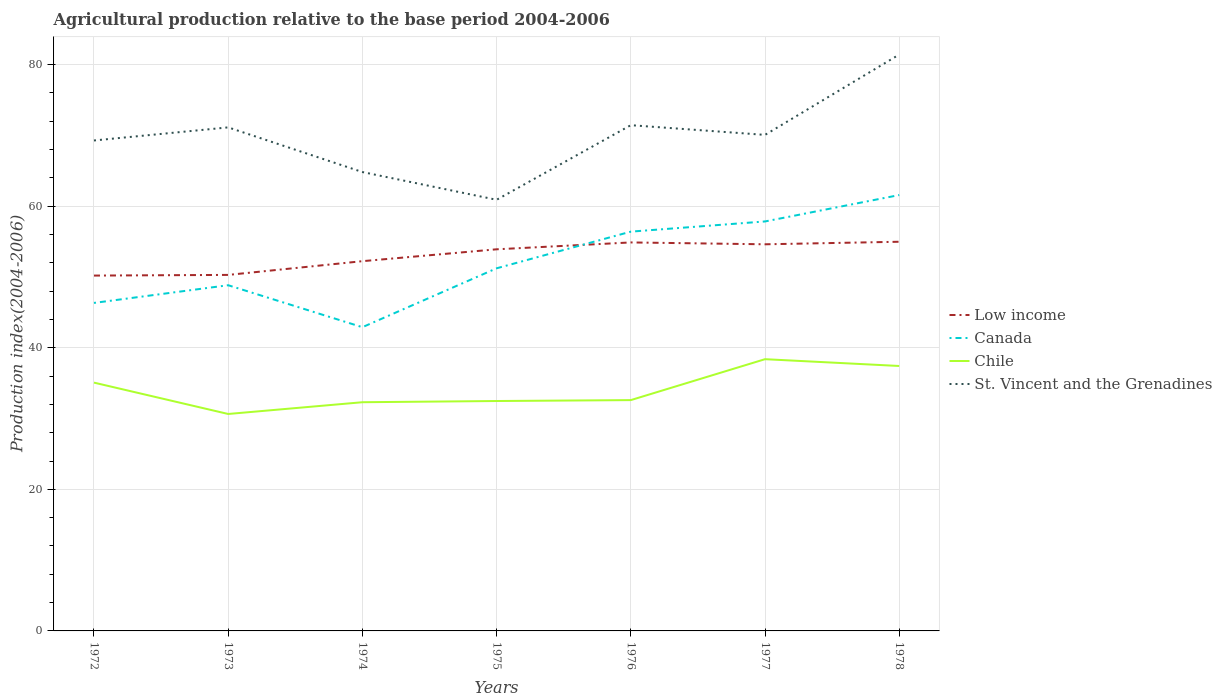Does the line corresponding to Chile intersect with the line corresponding to Canada?
Offer a very short reply. No. Is the number of lines equal to the number of legend labels?
Offer a very short reply. Yes. Across all years, what is the maximum agricultural production index in Low income?
Ensure brevity in your answer.  50.2. In which year was the agricultural production index in Canada maximum?
Keep it short and to the point. 1974. What is the total agricultural production index in Chile in the graph?
Keep it short and to the point. -0.13. What is the difference between the highest and the second highest agricultural production index in St. Vincent and the Grenadines?
Make the answer very short. 20.52. What is the difference between two consecutive major ticks on the Y-axis?
Provide a short and direct response. 20. Are the values on the major ticks of Y-axis written in scientific E-notation?
Your answer should be compact. No. Does the graph contain any zero values?
Make the answer very short. No. Does the graph contain grids?
Provide a short and direct response. Yes. Where does the legend appear in the graph?
Keep it short and to the point. Center right. How are the legend labels stacked?
Make the answer very short. Vertical. What is the title of the graph?
Make the answer very short. Agricultural production relative to the base period 2004-2006. What is the label or title of the X-axis?
Keep it short and to the point. Years. What is the label or title of the Y-axis?
Keep it short and to the point. Production index(2004-2006). What is the Production index(2004-2006) in Low income in 1972?
Provide a succinct answer. 50.2. What is the Production index(2004-2006) in Canada in 1972?
Provide a succinct answer. 46.34. What is the Production index(2004-2006) of Chile in 1972?
Give a very brief answer. 35.08. What is the Production index(2004-2006) of St. Vincent and the Grenadines in 1972?
Make the answer very short. 69.29. What is the Production index(2004-2006) in Low income in 1973?
Your answer should be compact. 50.3. What is the Production index(2004-2006) in Canada in 1973?
Provide a succinct answer. 48.84. What is the Production index(2004-2006) of Chile in 1973?
Offer a terse response. 30.65. What is the Production index(2004-2006) in St. Vincent and the Grenadines in 1973?
Your response must be concise. 71.14. What is the Production index(2004-2006) in Low income in 1974?
Your answer should be compact. 52.24. What is the Production index(2004-2006) in Canada in 1974?
Your answer should be very brief. 42.91. What is the Production index(2004-2006) in Chile in 1974?
Provide a short and direct response. 32.31. What is the Production index(2004-2006) of St. Vincent and the Grenadines in 1974?
Provide a succinct answer. 64.83. What is the Production index(2004-2006) of Low income in 1975?
Make the answer very short. 53.92. What is the Production index(2004-2006) of Canada in 1975?
Provide a succinct answer. 51.23. What is the Production index(2004-2006) of Chile in 1975?
Keep it short and to the point. 32.48. What is the Production index(2004-2006) of St. Vincent and the Grenadines in 1975?
Provide a short and direct response. 60.91. What is the Production index(2004-2006) in Low income in 1976?
Keep it short and to the point. 54.89. What is the Production index(2004-2006) in Canada in 1976?
Your answer should be compact. 56.41. What is the Production index(2004-2006) of Chile in 1976?
Ensure brevity in your answer.  32.61. What is the Production index(2004-2006) in St. Vincent and the Grenadines in 1976?
Ensure brevity in your answer.  71.45. What is the Production index(2004-2006) of Low income in 1977?
Your answer should be very brief. 54.62. What is the Production index(2004-2006) in Canada in 1977?
Offer a very short reply. 57.85. What is the Production index(2004-2006) of Chile in 1977?
Give a very brief answer. 38.39. What is the Production index(2004-2006) in St. Vincent and the Grenadines in 1977?
Your answer should be compact. 70.08. What is the Production index(2004-2006) in Low income in 1978?
Provide a short and direct response. 54.98. What is the Production index(2004-2006) in Canada in 1978?
Provide a short and direct response. 61.58. What is the Production index(2004-2006) in Chile in 1978?
Ensure brevity in your answer.  37.43. What is the Production index(2004-2006) in St. Vincent and the Grenadines in 1978?
Provide a short and direct response. 81.43. Across all years, what is the maximum Production index(2004-2006) of Low income?
Provide a short and direct response. 54.98. Across all years, what is the maximum Production index(2004-2006) in Canada?
Keep it short and to the point. 61.58. Across all years, what is the maximum Production index(2004-2006) of Chile?
Offer a very short reply. 38.39. Across all years, what is the maximum Production index(2004-2006) in St. Vincent and the Grenadines?
Offer a terse response. 81.43. Across all years, what is the minimum Production index(2004-2006) of Low income?
Give a very brief answer. 50.2. Across all years, what is the minimum Production index(2004-2006) in Canada?
Provide a short and direct response. 42.91. Across all years, what is the minimum Production index(2004-2006) in Chile?
Offer a very short reply. 30.65. Across all years, what is the minimum Production index(2004-2006) of St. Vincent and the Grenadines?
Provide a short and direct response. 60.91. What is the total Production index(2004-2006) in Low income in the graph?
Offer a very short reply. 371.14. What is the total Production index(2004-2006) in Canada in the graph?
Offer a terse response. 365.16. What is the total Production index(2004-2006) of Chile in the graph?
Keep it short and to the point. 238.95. What is the total Production index(2004-2006) in St. Vincent and the Grenadines in the graph?
Offer a terse response. 489.13. What is the difference between the Production index(2004-2006) of Low income in 1972 and that in 1973?
Provide a succinct answer. -0.09. What is the difference between the Production index(2004-2006) in Chile in 1972 and that in 1973?
Provide a succinct answer. 4.43. What is the difference between the Production index(2004-2006) in St. Vincent and the Grenadines in 1972 and that in 1973?
Give a very brief answer. -1.85. What is the difference between the Production index(2004-2006) of Low income in 1972 and that in 1974?
Your answer should be compact. -2.03. What is the difference between the Production index(2004-2006) in Canada in 1972 and that in 1974?
Provide a short and direct response. 3.43. What is the difference between the Production index(2004-2006) in Chile in 1972 and that in 1974?
Keep it short and to the point. 2.77. What is the difference between the Production index(2004-2006) of St. Vincent and the Grenadines in 1972 and that in 1974?
Your answer should be compact. 4.46. What is the difference between the Production index(2004-2006) in Low income in 1972 and that in 1975?
Offer a very short reply. -3.71. What is the difference between the Production index(2004-2006) of Canada in 1972 and that in 1975?
Keep it short and to the point. -4.89. What is the difference between the Production index(2004-2006) of Chile in 1972 and that in 1975?
Ensure brevity in your answer.  2.6. What is the difference between the Production index(2004-2006) of St. Vincent and the Grenadines in 1972 and that in 1975?
Provide a succinct answer. 8.38. What is the difference between the Production index(2004-2006) in Low income in 1972 and that in 1976?
Offer a very short reply. -4.68. What is the difference between the Production index(2004-2006) of Canada in 1972 and that in 1976?
Offer a very short reply. -10.07. What is the difference between the Production index(2004-2006) of Chile in 1972 and that in 1976?
Your answer should be compact. 2.47. What is the difference between the Production index(2004-2006) of St. Vincent and the Grenadines in 1972 and that in 1976?
Offer a very short reply. -2.16. What is the difference between the Production index(2004-2006) in Low income in 1972 and that in 1977?
Your response must be concise. -4.42. What is the difference between the Production index(2004-2006) in Canada in 1972 and that in 1977?
Your answer should be compact. -11.51. What is the difference between the Production index(2004-2006) of Chile in 1972 and that in 1977?
Make the answer very short. -3.31. What is the difference between the Production index(2004-2006) of St. Vincent and the Grenadines in 1972 and that in 1977?
Your answer should be compact. -0.79. What is the difference between the Production index(2004-2006) in Low income in 1972 and that in 1978?
Your answer should be compact. -4.78. What is the difference between the Production index(2004-2006) of Canada in 1972 and that in 1978?
Your response must be concise. -15.24. What is the difference between the Production index(2004-2006) of Chile in 1972 and that in 1978?
Offer a very short reply. -2.35. What is the difference between the Production index(2004-2006) of St. Vincent and the Grenadines in 1972 and that in 1978?
Offer a terse response. -12.14. What is the difference between the Production index(2004-2006) in Low income in 1973 and that in 1974?
Offer a very short reply. -1.94. What is the difference between the Production index(2004-2006) of Canada in 1973 and that in 1974?
Provide a succinct answer. 5.93. What is the difference between the Production index(2004-2006) of Chile in 1973 and that in 1974?
Ensure brevity in your answer.  -1.66. What is the difference between the Production index(2004-2006) of St. Vincent and the Grenadines in 1973 and that in 1974?
Make the answer very short. 6.31. What is the difference between the Production index(2004-2006) in Low income in 1973 and that in 1975?
Your answer should be compact. -3.62. What is the difference between the Production index(2004-2006) in Canada in 1973 and that in 1975?
Offer a very short reply. -2.39. What is the difference between the Production index(2004-2006) of Chile in 1973 and that in 1975?
Your response must be concise. -1.83. What is the difference between the Production index(2004-2006) in St. Vincent and the Grenadines in 1973 and that in 1975?
Offer a terse response. 10.23. What is the difference between the Production index(2004-2006) in Low income in 1973 and that in 1976?
Your answer should be very brief. -4.59. What is the difference between the Production index(2004-2006) in Canada in 1973 and that in 1976?
Your answer should be very brief. -7.57. What is the difference between the Production index(2004-2006) in Chile in 1973 and that in 1976?
Your answer should be compact. -1.96. What is the difference between the Production index(2004-2006) in St. Vincent and the Grenadines in 1973 and that in 1976?
Make the answer very short. -0.31. What is the difference between the Production index(2004-2006) of Low income in 1973 and that in 1977?
Your response must be concise. -4.32. What is the difference between the Production index(2004-2006) of Canada in 1973 and that in 1977?
Offer a terse response. -9.01. What is the difference between the Production index(2004-2006) of Chile in 1973 and that in 1977?
Give a very brief answer. -7.74. What is the difference between the Production index(2004-2006) of St. Vincent and the Grenadines in 1973 and that in 1977?
Offer a very short reply. 1.06. What is the difference between the Production index(2004-2006) of Low income in 1973 and that in 1978?
Provide a succinct answer. -4.68. What is the difference between the Production index(2004-2006) in Canada in 1973 and that in 1978?
Provide a succinct answer. -12.74. What is the difference between the Production index(2004-2006) in Chile in 1973 and that in 1978?
Keep it short and to the point. -6.78. What is the difference between the Production index(2004-2006) in St. Vincent and the Grenadines in 1973 and that in 1978?
Offer a terse response. -10.29. What is the difference between the Production index(2004-2006) of Low income in 1974 and that in 1975?
Your answer should be compact. -1.68. What is the difference between the Production index(2004-2006) of Canada in 1974 and that in 1975?
Your answer should be compact. -8.32. What is the difference between the Production index(2004-2006) in Chile in 1974 and that in 1975?
Keep it short and to the point. -0.17. What is the difference between the Production index(2004-2006) of St. Vincent and the Grenadines in 1974 and that in 1975?
Keep it short and to the point. 3.92. What is the difference between the Production index(2004-2006) of Low income in 1974 and that in 1976?
Keep it short and to the point. -2.65. What is the difference between the Production index(2004-2006) of St. Vincent and the Grenadines in 1974 and that in 1976?
Your answer should be very brief. -6.62. What is the difference between the Production index(2004-2006) in Low income in 1974 and that in 1977?
Your response must be concise. -2.39. What is the difference between the Production index(2004-2006) of Canada in 1974 and that in 1977?
Offer a very short reply. -14.94. What is the difference between the Production index(2004-2006) of Chile in 1974 and that in 1977?
Provide a succinct answer. -6.08. What is the difference between the Production index(2004-2006) of St. Vincent and the Grenadines in 1974 and that in 1977?
Provide a short and direct response. -5.25. What is the difference between the Production index(2004-2006) in Low income in 1974 and that in 1978?
Offer a very short reply. -2.75. What is the difference between the Production index(2004-2006) of Canada in 1974 and that in 1978?
Keep it short and to the point. -18.67. What is the difference between the Production index(2004-2006) of Chile in 1974 and that in 1978?
Provide a succinct answer. -5.12. What is the difference between the Production index(2004-2006) of St. Vincent and the Grenadines in 1974 and that in 1978?
Offer a very short reply. -16.6. What is the difference between the Production index(2004-2006) of Low income in 1975 and that in 1976?
Give a very brief answer. -0.97. What is the difference between the Production index(2004-2006) of Canada in 1975 and that in 1976?
Make the answer very short. -5.18. What is the difference between the Production index(2004-2006) in Chile in 1975 and that in 1976?
Give a very brief answer. -0.13. What is the difference between the Production index(2004-2006) in St. Vincent and the Grenadines in 1975 and that in 1976?
Your response must be concise. -10.54. What is the difference between the Production index(2004-2006) in Low income in 1975 and that in 1977?
Make the answer very short. -0.71. What is the difference between the Production index(2004-2006) of Canada in 1975 and that in 1977?
Keep it short and to the point. -6.62. What is the difference between the Production index(2004-2006) of Chile in 1975 and that in 1977?
Your answer should be compact. -5.91. What is the difference between the Production index(2004-2006) in St. Vincent and the Grenadines in 1975 and that in 1977?
Provide a succinct answer. -9.17. What is the difference between the Production index(2004-2006) of Low income in 1975 and that in 1978?
Offer a very short reply. -1.07. What is the difference between the Production index(2004-2006) in Canada in 1975 and that in 1978?
Make the answer very short. -10.35. What is the difference between the Production index(2004-2006) in Chile in 1975 and that in 1978?
Give a very brief answer. -4.95. What is the difference between the Production index(2004-2006) of St. Vincent and the Grenadines in 1975 and that in 1978?
Offer a terse response. -20.52. What is the difference between the Production index(2004-2006) in Low income in 1976 and that in 1977?
Offer a terse response. 0.26. What is the difference between the Production index(2004-2006) of Canada in 1976 and that in 1977?
Your response must be concise. -1.44. What is the difference between the Production index(2004-2006) in Chile in 1976 and that in 1977?
Your answer should be very brief. -5.78. What is the difference between the Production index(2004-2006) of St. Vincent and the Grenadines in 1976 and that in 1977?
Your response must be concise. 1.37. What is the difference between the Production index(2004-2006) of Low income in 1976 and that in 1978?
Provide a short and direct response. -0.1. What is the difference between the Production index(2004-2006) in Canada in 1976 and that in 1978?
Offer a very short reply. -5.17. What is the difference between the Production index(2004-2006) in Chile in 1976 and that in 1978?
Ensure brevity in your answer.  -4.82. What is the difference between the Production index(2004-2006) in St. Vincent and the Grenadines in 1976 and that in 1978?
Give a very brief answer. -9.98. What is the difference between the Production index(2004-2006) in Low income in 1977 and that in 1978?
Give a very brief answer. -0.36. What is the difference between the Production index(2004-2006) in Canada in 1977 and that in 1978?
Offer a very short reply. -3.73. What is the difference between the Production index(2004-2006) in Chile in 1977 and that in 1978?
Ensure brevity in your answer.  0.96. What is the difference between the Production index(2004-2006) in St. Vincent and the Grenadines in 1977 and that in 1978?
Your answer should be compact. -11.35. What is the difference between the Production index(2004-2006) of Low income in 1972 and the Production index(2004-2006) of Canada in 1973?
Provide a short and direct response. 1.36. What is the difference between the Production index(2004-2006) in Low income in 1972 and the Production index(2004-2006) in Chile in 1973?
Make the answer very short. 19.55. What is the difference between the Production index(2004-2006) in Low income in 1972 and the Production index(2004-2006) in St. Vincent and the Grenadines in 1973?
Make the answer very short. -20.94. What is the difference between the Production index(2004-2006) in Canada in 1972 and the Production index(2004-2006) in Chile in 1973?
Offer a terse response. 15.69. What is the difference between the Production index(2004-2006) of Canada in 1972 and the Production index(2004-2006) of St. Vincent and the Grenadines in 1973?
Offer a very short reply. -24.8. What is the difference between the Production index(2004-2006) of Chile in 1972 and the Production index(2004-2006) of St. Vincent and the Grenadines in 1973?
Give a very brief answer. -36.06. What is the difference between the Production index(2004-2006) in Low income in 1972 and the Production index(2004-2006) in Canada in 1974?
Give a very brief answer. 7.29. What is the difference between the Production index(2004-2006) of Low income in 1972 and the Production index(2004-2006) of Chile in 1974?
Offer a very short reply. 17.89. What is the difference between the Production index(2004-2006) of Low income in 1972 and the Production index(2004-2006) of St. Vincent and the Grenadines in 1974?
Offer a terse response. -14.63. What is the difference between the Production index(2004-2006) in Canada in 1972 and the Production index(2004-2006) in Chile in 1974?
Keep it short and to the point. 14.03. What is the difference between the Production index(2004-2006) in Canada in 1972 and the Production index(2004-2006) in St. Vincent and the Grenadines in 1974?
Provide a short and direct response. -18.49. What is the difference between the Production index(2004-2006) of Chile in 1972 and the Production index(2004-2006) of St. Vincent and the Grenadines in 1974?
Your answer should be compact. -29.75. What is the difference between the Production index(2004-2006) of Low income in 1972 and the Production index(2004-2006) of Canada in 1975?
Your answer should be very brief. -1.03. What is the difference between the Production index(2004-2006) of Low income in 1972 and the Production index(2004-2006) of Chile in 1975?
Your answer should be very brief. 17.72. What is the difference between the Production index(2004-2006) in Low income in 1972 and the Production index(2004-2006) in St. Vincent and the Grenadines in 1975?
Give a very brief answer. -10.71. What is the difference between the Production index(2004-2006) of Canada in 1972 and the Production index(2004-2006) of Chile in 1975?
Offer a very short reply. 13.86. What is the difference between the Production index(2004-2006) in Canada in 1972 and the Production index(2004-2006) in St. Vincent and the Grenadines in 1975?
Offer a very short reply. -14.57. What is the difference between the Production index(2004-2006) in Chile in 1972 and the Production index(2004-2006) in St. Vincent and the Grenadines in 1975?
Provide a succinct answer. -25.83. What is the difference between the Production index(2004-2006) of Low income in 1972 and the Production index(2004-2006) of Canada in 1976?
Provide a succinct answer. -6.21. What is the difference between the Production index(2004-2006) of Low income in 1972 and the Production index(2004-2006) of Chile in 1976?
Ensure brevity in your answer.  17.59. What is the difference between the Production index(2004-2006) of Low income in 1972 and the Production index(2004-2006) of St. Vincent and the Grenadines in 1976?
Your answer should be compact. -21.25. What is the difference between the Production index(2004-2006) of Canada in 1972 and the Production index(2004-2006) of Chile in 1976?
Your response must be concise. 13.73. What is the difference between the Production index(2004-2006) in Canada in 1972 and the Production index(2004-2006) in St. Vincent and the Grenadines in 1976?
Your response must be concise. -25.11. What is the difference between the Production index(2004-2006) in Chile in 1972 and the Production index(2004-2006) in St. Vincent and the Grenadines in 1976?
Make the answer very short. -36.37. What is the difference between the Production index(2004-2006) of Low income in 1972 and the Production index(2004-2006) of Canada in 1977?
Provide a short and direct response. -7.65. What is the difference between the Production index(2004-2006) of Low income in 1972 and the Production index(2004-2006) of Chile in 1977?
Keep it short and to the point. 11.81. What is the difference between the Production index(2004-2006) of Low income in 1972 and the Production index(2004-2006) of St. Vincent and the Grenadines in 1977?
Keep it short and to the point. -19.88. What is the difference between the Production index(2004-2006) of Canada in 1972 and the Production index(2004-2006) of Chile in 1977?
Provide a short and direct response. 7.95. What is the difference between the Production index(2004-2006) in Canada in 1972 and the Production index(2004-2006) in St. Vincent and the Grenadines in 1977?
Your response must be concise. -23.74. What is the difference between the Production index(2004-2006) in Chile in 1972 and the Production index(2004-2006) in St. Vincent and the Grenadines in 1977?
Make the answer very short. -35. What is the difference between the Production index(2004-2006) of Low income in 1972 and the Production index(2004-2006) of Canada in 1978?
Your answer should be compact. -11.38. What is the difference between the Production index(2004-2006) of Low income in 1972 and the Production index(2004-2006) of Chile in 1978?
Your answer should be compact. 12.77. What is the difference between the Production index(2004-2006) in Low income in 1972 and the Production index(2004-2006) in St. Vincent and the Grenadines in 1978?
Ensure brevity in your answer.  -31.23. What is the difference between the Production index(2004-2006) of Canada in 1972 and the Production index(2004-2006) of Chile in 1978?
Provide a short and direct response. 8.91. What is the difference between the Production index(2004-2006) in Canada in 1972 and the Production index(2004-2006) in St. Vincent and the Grenadines in 1978?
Your response must be concise. -35.09. What is the difference between the Production index(2004-2006) of Chile in 1972 and the Production index(2004-2006) of St. Vincent and the Grenadines in 1978?
Provide a short and direct response. -46.35. What is the difference between the Production index(2004-2006) of Low income in 1973 and the Production index(2004-2006) of Canada in 1974?
Your answer should be compact. 7.39. What is the difference between the Production index(2004-2006) in Low income in 1973 and the Production index(2004-2006) in Chile in 1974?
Provide a succinct answer. 17.99. What is the difference between the Production index(2004-2006) in Low income in 1973 and the Production index(2004-2006) in St. Vincent and the Grenadines in 1974?
Give a very brief answer. -14.53. What is the difference between the Production index(2004-2006) of Canada in 1973 and the Production index(2004-2006) of Chile in 1974?
Offer a terse response. 16.53. What is the difference between the Production index(2004-2006) in Canada in 1973 and the Production index(2004-2006) in St. Vincent and the Grenadines in 1974?
Give a very brief answer. -15.99. What is the difference between the Production index(2004-2006) of Chile in 1973 and the Production index(2004-2006) of St. Vincent and the Grenadines in 1974?
Ensure brevity in your answer.  -34.18. What is the difference between the Production index(2004-2006) of Low income in 1973 and the Production index(2004-2006) of Canada in 1975?
Offer a very short reply. -0.93. What is the difference between the Production index(2004-2006) in Low income in 1973 and the Production index(2004-2006) in Chile in 1975?
Offer a very short reply. 17.82. What is the difference between the Production index(2004-2006) in Low income in 1973 and the Production index(2004-2006) in St. Vincent and the Grenadines in 1975?
Your answer should be very brief. -10.61. What is the difference between the Production index(2004-2006) in Canada in 1973 and the Production index(2004-2006) in Chile in 1975?
Your answer should be very brief. 16.36. What is the difference between the Production index(2004-2006) of Canada in 1973 and the Production index(2004-2006) of St. Vincent and the Grenadines in 1975?
Provide a short and direct response. -12.07. What is the difference between the Production index(2004-2006) of Chile in 1973 and the Production index(2004-2006) of St. Vincent and the Grenadines in 1975?
Provide a short and direct response. -30.26. What is the difference between the Production index(2004-2006) in Low income in 1973 and the Production index(2004-2006) in Canada in 1976?
Offer a terse response. -6.11. What is the difference between the Production index(2004-2006) of Low income in 1973 and the Production index(2004-2006) of Chile in 1976?
Your answer should be very brief. 17.69. What is the difference between the Production index(2004-2006) in Low income in 1973 and the Production index(2004-2006) in St. Vincent and the Grenadines in 1976?
Keep it short and to the point. -21.15. What is the difference between the Production index(2004-2006) in Canada in 1973 and the Production index(2004-2006) in Chile in 1976?
Your answer should be compact. 16.23. What is the difference between the Production index(2004-2006) in Canada in 1973 and the Production index(2004-2006) in St. Vincent and the Grenadines in 1976?
Your answer should be very brief. -22.61. What is the difference between the Production index(2004-2006) of Chile in 1973 and the Production index(2004-2006) of St. Vincent and the Grenadines in 1976?
Provide a short and direct response. -40.8. What is the difference between the Production index(2004-2006) of Low income in 1973 and the Production index(2004-2006) of Canada in 1977?
Make the answer very short. -7.55. What is the difference between the Production index(2004-2006) in Low income in 1973 and the Production index(2004-2006) in Chile in 1977?
Offer a terse response. 11.91. What is the difference between the Production index(2004-2006) of Low income in 1973 and the Production index(2004-2006) of St. Vincent and the Grenadines in 1977?
Make the answer very short. -19.78. What is the difference between the Production index(2004-2006) of Canada in 1973 and the Production index(2004-2006) of Chile in 1977?
Make the answer very short. 10.45. What is the difference between the Production index(2004-2006) of Canada in 1973 and the Production index(2004-2006) of St. Vincent and the Grenadines in 1977?
Offer a very short reply. -21.24. What is the difference between the Production index(2004-2006) of Chile in 1973 and the Production index(2004-2006) of St. Vincent and the Grenadines in 1977?
Your response must be concise. -39.43. What is the difference between the Production index(2004-2006) in Low income in 1973 and the Production index(2004-2006) in Canada in 1978?
Provide a short and direct response. -11.28. What is the difference between the Production index(2004-2006) in Low income in 1973 and the Production index(2004-2006) in Chile in 1978?
Offer a very short reply. 12.87. What is the difference between the Production index(2004-2006) of Low income in 1973 and the Production index(2004-2006) of St. Vincent and the Grenadines in 1978?
Keep it short and to the point. -31.13. What is the difference between the Production index(2004-2006) in Canada in 1973 and the Production index(2004-2006) in Chile in 1978?
Your answer should be compact. 11.41. What is the difference between the Production index(2004-2006) in Canada in 1973 and the Production index(2004-2006) in St. Vincent and the Grenadines in 1978?
Provide a succinct answer. -32.59. What is the difference between the Production index(2004-2006) in Chile in 1973 and the Production index(2004-2006) in St. Vincent and the Grenadines in 1978?
Give a very brief answer. -50.78. What is the difference between the Production index(2004-2006) of Low income in 1974 and the Production index(2004-2006) of Chile in 1975?
Ensure brevity in your answer.  19.76. What is the difference between the Production index(2004-2006) of Low income in 1974 and the Production index(2004-2006) of St. Vincent and the Grenadines in 1975?
Your response must be concise. -8.67. What is the difference between the Production index(2004-2006) of Canada in 1974 and the Production index(2004-2006) of Chile in 1975?
Offer a very short reply. 10.43. What is the difference between the Production index(2004-2006) in Chile in 1974 and the Production index(2004-2006) in St. Vincent and the Grenadines in 1975?
Your response must be concise. -28.6. What is the difference between the Production index(2004-2006) in Low income in 1974 and the Production index(2004-2006) in Canada in 1976?
Provide a short and direct response. -4.17. What is the difference between the Production index(2004-2006) of Low income in 1974 and the Production index(2004-2006) of Chile in 1976?
Ensure brevity in your answer.  19.63. What is the difference between the Production index(2004-2006) in Low income in 1974 and the Production index(2004-2006) in St. Vincent and the Grenadines in 1976?
Ensure brevity in your answer.  -19.21. What is the difference between the Production index(2004-2006) in Canada in 1974 and the Production index(2004-2006) in Chile in 1976?
Offer a terse response. 10.3. What is the difference between the Production index(2004-2006) in Canada in 1974 and the Production index(2004-2006) in St. Vincent and the Grenadines in 1976?
Your response must be concise. -28.54. What is the difference between the Production index(2004-2006) in Chile in 1974 and the Production index(2004-2006) in St. Vincent and the Grenadines in 1976?
Make the answer very short. -39.14. What is the difference between the Production index(2004-2006) of Low income in 1974 and the Production index(2004-2006) of Canada in 1977?
Your response must be concise. -5.61. What is the difference between the Production index(2004-2006) in Low income in 1974 and the Production index(2004-2006) in Chile in 1977?
Give a very brief answer. 13.85. What is the difference between the Production index(2004-2006) of Low income in 1974 and the Production index(2004-2006) of St. Vincent and the Grenadines in 1977?
Give a very brief answer. -17.84. What is the difference between the Production index(2004-2006) of Canada in 1974 and the Production index(2004-2006) of Chile in 1977?
Provide a short and direct response. 4.52. What is the difference between the Production index(2004-2006) of Canada in 1974 and the Production index(2004-2006) of St. Vincent and the Grenadines in 1977?
Offer a very short reply. -27.17. What is the difference between the Production index(2004-2006) of Chile in 1974 and the Production index(2004-2006) of St. Vincent and the Grenadines in 1977?
Your response must be concise. -37.77. What is the difference between the Production index(2004-2006) in Low income in 1974 and the Production index(2004-2006) in Canada in 1978?
Keep it short and to the point. -9.34. What is the difference between the Production index(2004-2006) in Low income in 1974 and the Production index(2004-2006) in Chile in 1978?
Provide a succinct answer. 14.81. What is the difference between the Production index(2004-2006) of Low income in 1974 and the Production index(2004-2006) of St. Vincent and the Grenadines in 1978?
Give a very brief answer. -29.19. What is the difference between the Production index(2004-2006) of Canada in 1974 and the Production index(2004-2006) of Chile in 1978?
Provide a short and direct response. 5.48. What is the difference between the Production index(2004-2006) in Canada in 1974 and the Production index(2004-2006) in St. Vincent and the Grenadines in 1978?
Give a very brief answer. -38.52. What is the difference between the Production index(2004-2006) of Chile in 1974 and the Production index(2004-2006) of St. Vincent and the Grenadines in 1978?
Give a very brief answer. -49.12. What is the difference between the Production index(2004-2006) in Low income in 1975 and the Production index(2004-2006) in Canada in 1976?
Provide a succinct answer. -2.49. What is the difference between the Production index(2004-2006) in Low income in 1975 and the Production index(2004-2006) in Chile in 1976?
Make the answer very short. 21.31. What is the difference between the Production index(2004-2006) of Low income in 1975 and the Production index(2004-2006) of St. Vincent and the Grenadines in 1976?
Make the answer very short. -17.53. What is the difference between the Production index(2004-2006) in Canada in 1975 and the Production index(2004-2006) in Chile in 1976?
Your response must be concise. 18.62. What is the difference between the Production index(2004-2006) of Canada in 1975 and the Production index(2004-2006) of St. Vincent and the Grenadines in 1976?
Make the answer very short. -20.22. What is the difference between the Production index(2004-2006) in Chile in 1975 and the Production index(2004-2006) in St. Vincent and the Grenadines in 1976?
Keep it short and to the point. -38.97. What is the difference between the Production index(2004-2006) of Low income in 1975 and the Production index(2004-2006) of Canada in 1977?
Offer a very short reply. -3.93. What is the difference between the Production index(2004-2006) of Low income in 1975 and the Production index(2004-2006) of Chile in 1977?
Your answer should be compact. 15.53. What is the difference between the Production index(2004-2006) of Low income in 1975 and the Production index(2004-2006) of St. Vincent and the Grenadines in 1977?
Your response must be concise. -16.16. What is the difference between the Production index(2004-2006) of Canada in 1975 and the Production index(2004-2006) of Chile in 1977?
Provide a succinct answer. 12.84. What is the difference between the Production index(2004-2006) in Canada in 1975 and the Production index(2004-2006) in St. Vincent and the Grenadines in 1977?
Provide a short and direct response. -18.85. What is the difference between the Production index(2004-2006) of Chile in 1975 and the Production index(2004-2006) of St. Vincent and the Grenadines in 1977?
Provide a succinct answer. -37.6. What is the difference between the Production index(2004-2006) of Low income in 1975 and the Production index(2004-2006) of Canada in 1978?
Your response must be concise. -7.66. What is the difference between the Production index(2004-2006) of Low income in 1975 and the Production index(2004-2006) of Chile in 1978?
Offer a terse response. 16.49. What is the difference between the Production index(2004-2006) in Low income in 1975 and the Production index(2004-2006) in St. Vincent and the Grenadines in 1978?
Offer a terse response. -27.51. What is the difference between the Production index(2004-2006) in Canada in 1975 and the Production index(2004-2006) in Chile in 1978?
Keep it short and to the point. 13.8. What is the difference between the Production index(2004-2006) of Canada in 1975 and the Production index(2004-2006) of St. Vincent and the Grenadines in 1978?
Your answer should be very brief. -30.2. What is the difference between the Production index(2004-2006) of Chile in 1975 and the Production index(2004-2006) of St. Vincent and the Grenadines in 1978?
Offer a very short reply. -48.95. What is the difference between the Production index(2004-2006) of Low income in 1976 and the Production index(2004-2006) of Canada in 1977?
Your response must be concise. -2.96. What is the difference between the Production index(2004-2006) of Low income in 1976 and the Production index(2004-2006) of Chile in 1977?
Keep it short and to the point. 16.5. What is the difference between the Production index(2004-2006) in Low income in 1976 and the Production index(2004-2006) in St. Vincent and the Grenadines in 1977?
Give a very brief answer. -15.19. What is the difference between the Production index(2004-2006) of Canada in 1976 and the Production index(2004-2006) of Chile in 1977?
Provide a succinct answer. 18.02. What is the difference between the Production index(2004-2006) of Canada in 1976 and the Production index(2004-2006) of St. Vincent and the Grenadines in 1977?
Keep it short and to the point. -13.67. What is the difference between the Production index(2004-2006) of Chile in 1976 and the Production index(2004-2006) of St. Vincent and the Grenadines in 1977?
Ensure brevity in your answer.  -37.47. What is the difference between the Production index(2004-2006) of Low income in 1976 and the Production index(2004-2006) of Canada in 1978?
Your answer should be very brief. -6.69. What is the difference between the Production index(2004-2006) of Low income in 1976 and the Production index(2004-2006) of Chile in 1978?
Offer a terse response. 17.46. What is the difference between the Production index(2004-2006) of Low income in 1976 and the Production index(2004-2006) of St. Vincent and the Grenadines in 1978?
Your answer should be compact. -26.54. What is the difference between the Production index(2004-2006) of Canada in 1976 and the Production index(2004-2006) of Chile in 1978?
Offer a very short reply. 18.98. What is the difference between the Production index(2004-2006) in Canada in 1976 and the Production index(2004-2006) in St. Vincent and the Grenadines in 1978?
Offer a terse response. -25.02. What is the difference between the Production index(2004-2006) of Chile in 1976 and the Production index(2004-2006) of St. Vincent and the Grenadines in 1978?
Offer a terse response. -48.82. What is the difference between the Production index(2004-2006) of Low income in 1977 and the Production index(2004-2006) of Canada in 1978?
Your answer should be very brief. -6.96. What is the difference between the Production index(2004-2006) of Low income in 1977 and the Production index(2004-2006) of Chile in 1978?
Provide a succinct answer. 17.19. What is the difference between the Production index(2004-2006) in Low income in 1977 and the Production index(2004-2006) in St. Vincent and the Grenadines in 1978?
Provide a short and direct response. -26.81. What is the difference between the Production index(2004-2006) of Canada in 1977 and the Production index(2004-2006) of Chile in 1978?
Your answer should be very brief. 20.42. What is the difference between the Production index(2004-2006) in Canada in 1977 and the Production index(2004-2006) in St. Vincent and the Grenadines in 1978?
Keep it short and to the point. -23.58. What is the difference between the Production index(2004-2006) of Chile in 1977 and the Production index(2004-2006) of St. Vincent and the Grenadines in 1978?
Offer a very short reply. -43.04. What is the average Production index(2004-2006) in Low income per year?
Ensure brevity in your answer.  53.02. What is the average Production index(2004-2006) of Canada per year?
Offer a very short reply. 52.17. What is the average Production index(2004-2006) in Chile per year?
Provide a short and direct response. 34.14. What is the average Production index(2004-2006) of St. Vincent and the Grenadines per year?
Provide a succinct answer. 69.88. In the year 1972, what is the difference between the Production index(2004-2006) of Low income and Production index(2004-2006) of Canada?
Your response must be concise. 3.86. In the year 1972, what is the difference between the Production index(2004-2006) in Low income and Production index(2004-2006) in Chile?
Provide a succinct answer. 15.12. In the year 1972, what is the difference between the Production index(2004-2006) in Low income and Production index(2004-2006) in St. Vincent and the Grenadines?
Keep it short and to the point. -19.09. In the year 1972, what is the difference between the Production index(2004-2006) in Canada and Production index(2004-2006) in Chile?
Give a very brief answer. 11.26. In the year 1972, what is the difference between the Production index(2004-2006) of Canada and Production index(2004-2006) of St. Vincent and the Grenadines?
Make the answer very short. -22.95. In the year 1972, what is the difference between the Production index(2004-2006) in Chile and Production index(2004-2006) in St. Vincent and the Grenadines?
Provide a short and direct response. -34.21. In the year 1973, what is the difference between the Production index(2004-2006) in Low income and Production index(2004-2006) in Canada?
Provide a succinct answer. 1.46. In the year 1973, what is the difference between the Production index(2004-2006) of Low income and Production index(2004-2006) of Chile?
Ensure brevity in your answer.  19.65. In the year 1973, what is the difference between the Production index(2004-2006) of Low income and Production index(2004-2006) of St. Vincent and the Grenadines?
Make the answer very short. -20.84. In the year 1973, what is the difference between the Production index(2004-2006) of Canada and Production index(2004-2006) of Chile?
Your response must be concise. 18.19. In the year 1973, what is the difference between the Production index(2004-2006) in Canada and Production index(2004-2006) in St. Vincent and the Grenadines?
Ensure brevity in your answer.  -22.3. In the year 1973, what is the difference between the Production index(2004-2006) in Chile and Production index(2004-2006) in St. Vincent and the Grenadines?
Your answer should be very brief. -40.49. In the year 1974, what is the difference between the Production index(2004-2006) of Low income and Production index(2004-2006) of Canada?
Provide a short and direct response. 9.33. In the year 1974, what is the difference between the Production index(2004-2006) of Low income and Production index(2004-2006) of Chile?
Your answer should be compact. 19.93. In the year 1974, what is the difference between the Production index(2004-2006) in Low income and Production index(2004-2006) in St. Vincent and the Grenadines?
Provide a succinct answer. -12.59. In the year 1974, what is the difference between the Production index(2004-2006) of Canada and Production index(2004-2006) of St. Vincent and the Grenadines?
Ensure brevity in your answer.  -21.92. In the year 1974, what is the difference between the Production index(2004-2006) of Chile and Production index(2004-2006) of St. Vincent and the Grenadines?
Keep it short and to the point. -32.52. In the year 1975, what is the difference between the Production index(2004-2006) of Low income and Production index(2004-2006) of Canada?
Offer a very short reply. 2.69. In the year 1975, what is the difference between the Production index(2004-2006) of Low income and Production index(2004-2006) of Chile?
Offer a very short reply. 21.44. In the year 1975, what is the difference between the Production index(2004-2006) of Low income and Production index(2004-2006) of St. Vincent and the Grenadines?
Offer a very short reply. -6.99. In the year 1975, what is the difference between the Production index(2004-2006) in Canada and Production index(2004-2006) in Chile?
Provide a succinct answer. 18.75. In the year 1975, what is the difference between the Production index(2004-2006) in Canada and Production index(2004-2006) in St. Vincent and the Grenadines?
Provide a short and direct response. -9.68. In the year 1975, what is the difference between the Production index(2004-2006) in Chile and Production index(2004-2006) in St. Vincent and the Grenadines?
Offer a terse response. -28.43. In the year 1976, what is the difference between the Production index(2004-2006) in Low income and Production index(2004-2006) in Canada?
Provide a short and direct response. -1.52. In the year 1976, what is the difference between the Production index(2004-2006) in Low income and Production index(2004-2006) in Chile?
Offer a very short reply. 22.28. In the year 1976, what is the difference between the Production index(2004-2006) in Low income and Production index(2004-2006) in St. Vincent and the Grenadines?
Provide a short and direct response. -16.56. In the year 1976, what is the difference between the Production index(2004-2006) in Canada and Production index(2004-2006) in Chile?
Ensure brevity in your answer.  23.8. In the year 1976, what is the difference between the Production index(2004-2006) in Canada and Production index(2004-2006) in St. Vincent and the Grenadines?
Provide a succinct answer. -15.04. In the year 1976, what is the difference between the Production index(2004-2006) in Chile and Production index(2004-2006) in St. Vincent and the Grenadines?
Offer a very short reply. -38.84. In the year 1977, what is the difference between the Production index(2004-2006) of Low income and Production index(2004-2006) of Canada?
Provide a succinct answer. -3.23. In the year 1977, what is the difference between the Production index(2004-2006) in Low income and Production index(2004-2006) in Chile?
Offer a terse response. 16.23. In the year 1977, what is the difference between the Production index(2004-2006) of Low income and Production index(2004-2006) of St. Vincent and the Grenadines?
Provide a succinct answer. -15.46. In the year 1977, what is the difference between the Production index(2004-2006) in Canada and Production index(2004-2006) in Chile?
Your response must be concise. 19.46. In the year 1977, what is the difference between the Production index(2004-2006) of Canada and Production index(2004-2006) of St. Vincent and the Grenadines?
Your response must be concise. -12.23. In the year 1977, what is the difference between the Production index(2004-2006) in Chile and Production index(2004-2006) in St. Vincent and the Grenadines?
Provide a succinct answer. -31.69. In the year 1978, what is the difference between the Production index(2004-2006) of Low income and Production index(2004-2006) of Canada?
Provide a succinct answer. -6.6. In the year 1978, what is the difference between the Production index(2004-2006) of Low income and Production index(2004-2006) of Chile?
Keep it short and to the point. 17.55. In the year 1978, what is the difference between the Production index(2004-2006) in Low income and Production index(2004-2006) in St. Vincent and the Grenadines?
Provide a short and direct response. -26.45. In the year 1978, what is the difference between the Production index(2004-2006) of Canada and Production index(2004-2006) of Chile?
Keep it short and to the point. 24.15. In the year 1978, what is the difference between the Production index(2004-2006) of Canada and Production index(2004-2006) of St. Vincent and the Grenadines?
Provide a succinct answer. -19.85. In the year 1978, what is the difference between the Production index(2004-2006) of Chile and Production index(2004-2006) of St. Vincent and the Grenadines?
Give a very brief answer. -44. What is the ratio of the Production index(2004-2006) of Low income in 1972 to that in 1973?
Offer a very short reply. 1. What is the ratio of the Production index(2004-2006) of Canada in 1972 to that in 1973?
Provide a short and direct response. 0.95. What is the ratio of the Production index(2004-2006) in Chile in 1972 to that in 1973?
Provide a succinct answer. 1.14. What is the ratio of the Production index(2004-2006) in Low income in 1972 to that in 1974?
Offer a very short reply. 0.96. What is the ratio of the Production index(2004-2006) in Canada in 1972 to that in 1974?
Offer a terse response. 1.08. What is the ratio of the Production index(2004-2006) of Chile in 1972 to that in 1974?
Ensure brevity in your answer.  1.09. What is the ratio of the Production index(2004-2006) in St. Vincent and the Grenadines in 1972 to that in 1974?
Offer a very short reply. 1.07. What is the ratio of the Production index(2004-2006) in Low income in 1972 to that in 1975?
Ensure brevity in your answer.  0.93. What is the ratio of the Production index(2004-2006) of Canada in 1972 to that in 1975?
Provide a short and direct response. 0.9. What is the ratio of the Production index(2004-2006) in Chile in 1972 to that in 1975?
Offer a very short reply. 1.08. What is the ratio of the Production index(2004-2006) of St. Vincent and the Grenadines in 1972 to that in 1975?
Provide a short and direct response. 1.14. What is the ratio of the Production index(2004-2006) of Low income in 1972 to that in 1976?
Offer a very short reply. 0.91. What is the ratio of the Production index(2004-2006) in Canada in 1972 to that in 1976?
Your answer should be very brief. 0.82. What is the ratio of the Production index(2004-2006) of Chile in 1972 to that in 1976?
Offer a very short reply. 1.08. What is the ratio of the Production index(2004-2006) in St. Vincent and the Grenadines in 1972 to that in 1976?
Ensure brevity in your answer.  0.97. What is the ratio of the Production index(2004-2006) of Low income in 1972 to that in 1977?
Your answer should be compact. 0.92. What is the ratio of the Production index(2004-2006) in Canada in 1972 to that in 1977?
Give a very brief answer. 0.8. What is the ratio of the Production index(2004-2006) in Chile in 1972 to that in 1977?
Provide a succinct answer. 0.91. What is the ratio of the Production index(2004-2006) in St. Vincent and the Grenadines in 1972 to that in 1977?
Provide a succinct answer. 0.99. What is the ratio of the Production index(2004-2006) in Low income in 1972 to that in 1978?
Your response must be concise. 0.91. What is the ratio of the Production index(2004-2006) in Canada in 1972 to that in 1978?
Your answer should be compact. 0.75. What is the ratio of the Production index(2004-2006) of Chile in 1972 to that in 1978?
Provide a short and direct response. 0.94. What is the ratio of the Production index(2004-2006) in St. Vincent and the Grenadines in 1972 to that in 1978?
Offer a very short reply. 0.85. What is the ratio of the Production index(2004-2006) of Low income in 1973 to that in 1974?
Your answer should be compact. 0.96. What is the ratio of the Production index(2004-2006) of Canada in 1973 to that in 1974?
Keep it short and to the point. 1.14. What is the ratio of the Production index(2004-2006) in Chile in 1973 to that in 1974?
Offer a terse response. 0.95. What is the ratio of the Production index(2004-2006) in St. Vincent and the Grenadines in 1973 to that in 1974?
Offer a terse response. 1.1. What is the ratio of the Production index(2004-2006) of Low income in 1973 to that in 1975?
Provide a short and direct response. 0.93. What is the ratio of the Production index(2004-2006) in Canada in 1973 to that in 1975?
Offer a very short reply. 0.95. What is the ratio of the Production index(2004-2006) in Chile in 1973 to that in 1975?
Ensure brevity in your answer.  0.94. What is the ratio of the Production index(2004-2006) in St. Vincent and the Grenadines in 1973 to that in 1975?
Give a very brief answer. 1.17. What is the ratio of the Production index(2004-2006) of Low income in 1973 to that in 1976?
Your answer should be very brief. 0.92. What is the ratio of the Production index(2004-2006) in Canada in 1973 to that in 1976?
Keep it short and to the point. 0.87. What is the ratio of the Production index(2004-2006) in Chile in 1973 to that in 1976?
Provide a succinct answer. 0.94. What is the ratio of the Production index(2004-2006) of St. Vincent and the Grenadines in 1973 to that in 1976?
Provide a short and direct response. 1. What is the ratio of the Production index(2004-2006) of Low income in 1973 to that in 1977?
Your response must be concise. 0.92. What is the ratio of the Production index(2004-2006) of Canada in 1973 to that in 1977?
Offer a terse response. 0.84. What is the ratio of the Production index(2004-2006) of Chile in 1973 to that in 1977?
Keep it short and to the point. 0.8. What is the ratio of the Production index(2004-2006) in St. Vincent and the Grenadines in 1973 to that in 1977?
Make the answer very short. 1.02. What is the ratio of the Production index(2004-2006) of Low income in 1973 to that in 1978?
Keep it short and to the point. 0.91. What is the ratio of the Production index(2004-2006) in Canada in 1973 to that in 1978?
Offer a terse response. 0.79. What is the ratio of the Production index(2004-2006) in Chile in 1973 to that in 1978?
Offer a terse response. 0.82. What is the ratio of the Production index(2004-2006) of St. Vincent and the Grenadines in 1973 to that in 1978?
Your response must be concise. 0.87. What is the ratio of the Production index(2004-2006) in Low income in 1974 to that in 1975?
Ensure brevity in your answer.  0.97. What is the ratio of the Production index(2004-2006) in Canada in 1974 to that in 1975?
Your response must be concise. 0.84. What is the ratio of the Production index(2004-2006) in Chile in 1974 to that in 1975?
Give a very brief answer. 0.99. What is the ratio of the Production index(2004-2006) of St. Vincent and the Grenadines in 1974 to that in 1975?
Offer a very short reply. 1.06. What is the ratio of the Production index(2004-2006) in Low income in 1974 to that in 1976?
Provide a short and direct response. 0.95. What is the ratio of the Production index(2004-2006) in Canada in 1974 to that in 1976?
Provide a succinct answer. 0.76. What is the ratio of the Production index(2004-2006) of Chile in 1974 to that in 1976?
Provide a short and direct response. 0.99. What is the ratio of the Production index(2004-2006) in St. Vincent and the Grenadines in 1974 to that in 1976?
Offer a terse response. 0.91. What is the ratio of the Production index(2004-2006) of Low income in 1974 to that in 1977?
Your answer should be very brief. 0.96. What is the ratio of the Production index(2004-2006) in Canada in 1974 to that in 1977?
Your response must be concise. 0.74. What is the ratio of the Production index(2004-2006) of Chile in 1974 to that in 1977?
Offer a terse response. 0.84. What is the ratio of the Production index(2004-2006) of St. Vincent and the Grenadines in 1974 to that in 1977?
Provide a succinct answer. 0.93. What is the ratio of the Production index(2004-2006) of Low income in 1974 to that in 1978?
Offer a very short reply. 0.95. What is the ratio of the Production index(2004-2006) in Canada in 1974 to that in 1978?
Your response must be concise. 0.7. What is the ratio of the Production index(2004-2006) in Chile in 1974 to that in 1978?
Your answer should be very brief. 0.86. What is the ratio of the Production index(2004-2006) in St. Vincent and the Grenadines in 1974 to that in 1978?
Ensure brevity in your answer.  0.8. What is the ratio of the Production index(2004-2006) of Low income in 1975 to that in 1976?
Keep it short and to the point. 0.98. What is the ratio of the Production index(2004-2006) in Canada in 1975 to that in 1976?
Your answer should be very brief. 0.91. What is the ratio of the Production index(2004-2006) in St. Vincent and the Grenadines in 1975 to that in 1976?
Provide a succinct answer. 0.85. What is the ratio of the Production index(2004-2006) in Low income in 1975 to that in 1977?
Keep it short and to the point. 0.99. What is the ratio of the Production index(2004-2006) in Canada in 1975 to that in 1977?
Your answer should be compact. 0.89. What is the ratio of the Production index(2004-2006) of Chile in 1975 to that in 1977?
Provide a short and direct response. 0.85. What is the ratio of the Production index(2004-2006) of St. Vincent and the Grenadines in 1975 to that in 1977?
Offer a very short reply. 0.87. What is the ratio of the Production index(2004-2006) of Low income in 1975 to that in 1978?
Ensure brevity in your answer.  0.98. What is the ratio of the Production index(2004-2006) of Canada in 1975 to that in 1978?
Offer a very short reply. 0.83. What is the ratio of the Production index(2004-2006) in Chile in 1975 to that in 1978?
Provide a succinct answer. 0.87. What is the ratio of the Production index(2004-2006) in St. Vincent and the Grenadines in 1975 to that in 1978?
Provide a succinct answer. 0.75. What is the ratio of the Production index(2004-2006) of Canada in 1976 to that in 1977?
Your response must be concise. 0.98. What is the ratio of the Production index(2004-2006) in Chile in 1976 to that in 1977?
Make the answer very short. 0.85. What is the ratio of the Production index(2004-2006) of St. Vincent and the Grenadines in 1976 to that in 1977?
Keep it short and to the point. 1.02. What is the ratio of the Production index(2004-2006) in Canada in 1976 to that in 1978?
Ensure brevity in your answer.  0.92. What is the ratio of the Production index(2004-2006) of Chile in 1976 to that in 1978?
Provide a succinct answer. 0.87. What is the ratio of the Production index(2004-2006) of St. Vincent and the Grenadines in 1976 to that in 1978?
Give a very brief answer. 0.88. What is the ratio of the Production index(2004-2006) in Canada in 1977 to that in 1978?
Provide a succinct answer. 0.94. What is the ratio of the Production index(2004-2006) of Chile in 1977 to that in 1978?
Offer a very short reply. 1.03. What is the ratio of the Production index(2004-2006) in St. Vincent and the Grenadines in 1977 to that in 1978?
Your response must be concise. 0.86. What is the difference between the highest and the second highest Production index(2004-2006) of Low income?
Your answer should be compact. 0.1. What is the difference between the highest and the second highest Production index(2004-2006) in Canada?
Your response must be concise. 3.73. What is the difference between the highest and the second highest Production index(2004-2006) of St. Vincent and the Grenadines?
Your answer should be very brief. 9.98. What is the difference between the highest and the lowest Production index(2004-2006) of Low income?
Your answer should be very brief. 4.78. What is the difference between the highest and the lowest Production index(2004-2006) of Canada?
Provide a succinct answer. 18.67. What is the difference between the highest and the lowest Production index(2004-2006) of Chile?
Your answer should be compact. 7.74. What is the difference between the highest and the lowest Production index(2004-2006) in St. Vincent and the Grenadines?
Your response must be concise. 20.52. 